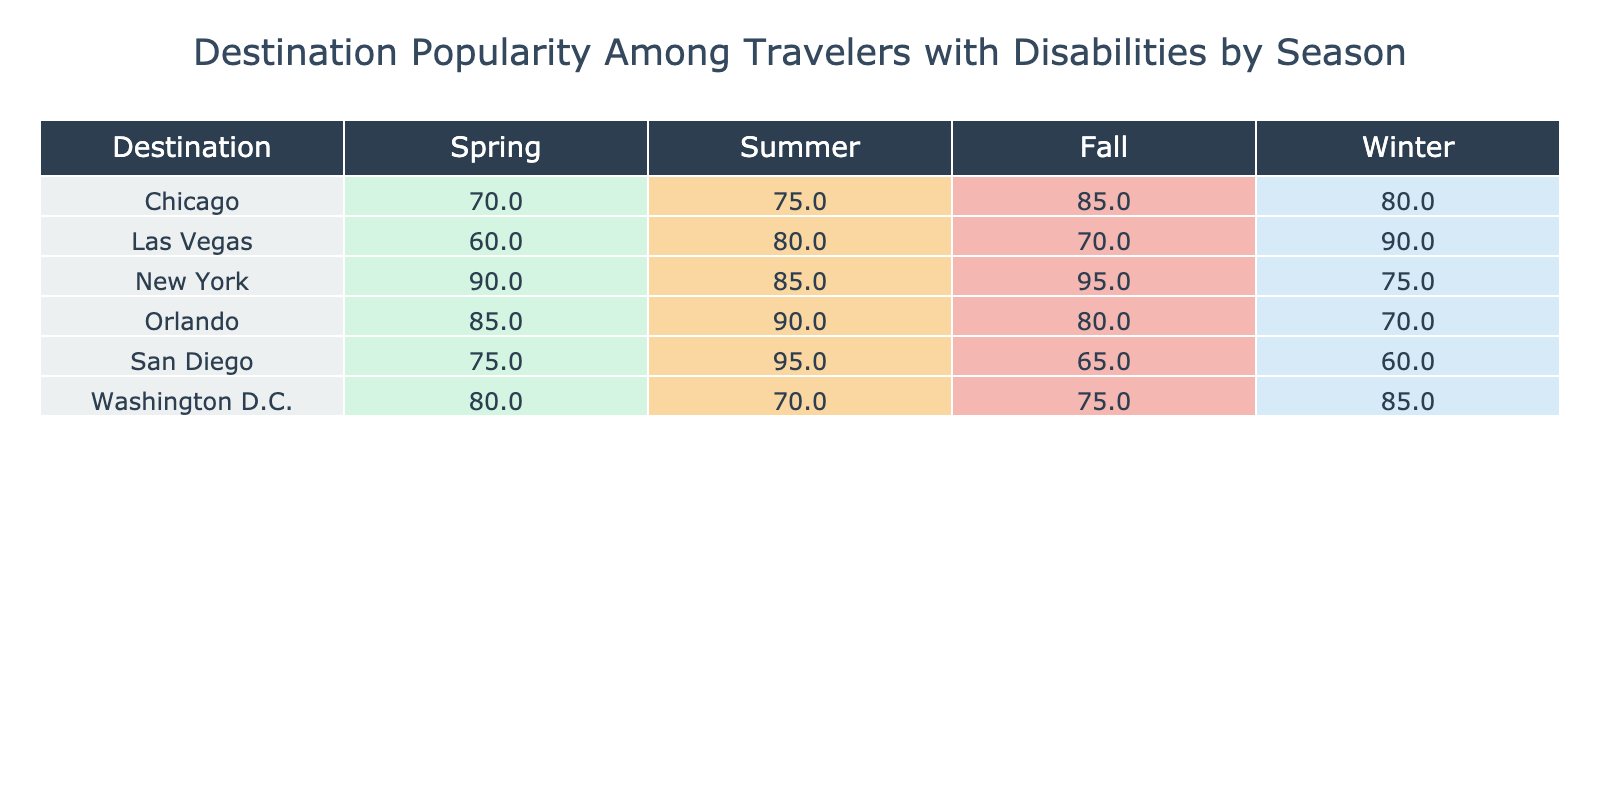What is the lowest popularity score for Orlando across all seasons? In the table, I look for Orlando's scores for each season: Spring (85), Summer (90), Fall (80), and Winter (70). Out of these values, Winter has the lowest score of 70.
Answer: 70 Which destination has the highest popularity score in Summer? By examining the summer scores, I see San Diego has a score of 95, which is higher than any other destination's summer scores: Orlando (90), New York (85), Washington D.C. (70), Las Vegas (80), and Chicago (75). So, the highest score in Summer is San Diego's 95.
Answer: San Diego What is the average popularity score for New York across all seasons? For New York, the scores are: Spring (90), Summer (85), Fall (95), and Winter (75). I calculate the average by summing these values (90 + 85 + 95 + 75 = 345) and dividing by the number of seasons (4), resulting in an average of 345 / 4 = 86.25.
Answer: 86.25 Does Washington D.C. have a higher popularity score in Spring compared to Fall? Looking at Washington D.C.’s scores, Spring is 80 and Fall is 75. Since 80 is greater than 75, it confirms that Washington D.C. indeed has a higher score in Spring than in Fall.
Answer: Yes What are the three lowest popularity scores in Spring? I first review the Spring scores for each destination: Orlando (85), San Diego (75), New York (90), Washington D.C. (80), Las Vegas (60), and Chicago (70). The three lowest scores are from Las Vegas (60), San Diego (75), and Chicago (70). Ordering these from lowest to highest gives us Las Vegas (60), San Diego (75), and Chicago (70).
Answer: Las Vegas, San Diego, Chicago Which season has the highest popularity score overall across all destinations? I examine the maximum scores for each season: Spring (90 from New York), Summer (95 from San Diego), Fall (95 from New York), and Winter (90 from Las Vegas). Since Summer and Fall both have a score of 95, I conclude that Summer and Fall tie as the seasons with the highest popularity scores.
Answer: Summer, Fall What destination has a popularity score of 60? I check the scores for each destination and see that Las Vegas has a score of 60 in Winter. Thus, Las Vegas is the only destination with a score of 60.
Answer: Las Vegas Which destination shows the greatest difference between its highest and lowest popularity scores? I identify the highest and lowest scores for each destination: Orlando (90 - 70 = 20), San Diego (95 - 60 = 35), New York (95 - 75 = 20), Washington D.C. (85 - 65 = 15), Las Vegas (90 - 60 = 30), and Chicago (85 - 70 = 15). Comparing these differences, San Diego has the greatest difference of 35.
Answer: San Diego 